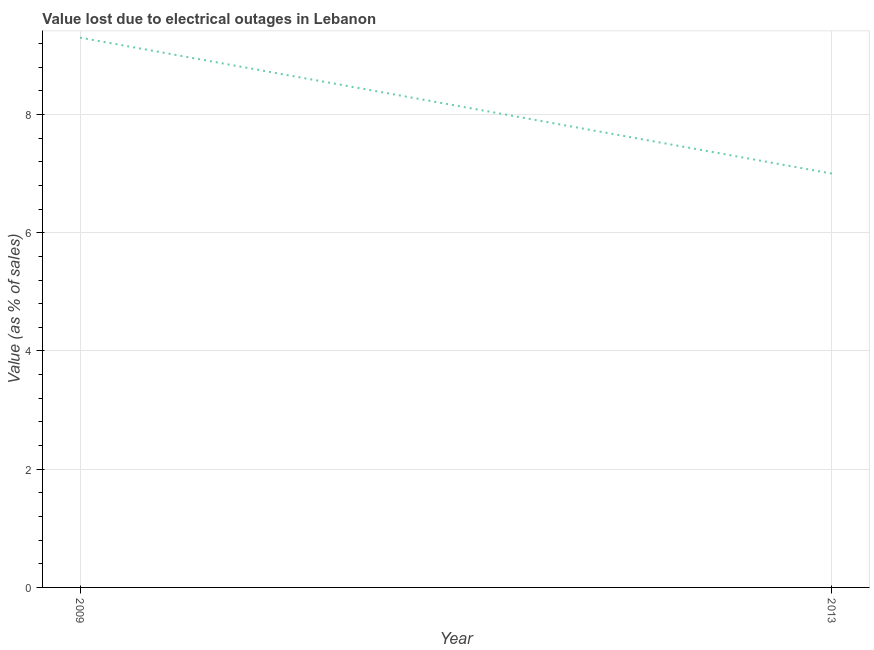What is the value lost due to electrical outages in 2009?
Keep it short and to the point. 9.3. Across all years, what is the maximum value lost due to electrical outages?
Make the answer very short. 9.3. Across all years, what is the minimum value lost due to electrical outages?
Your answer should be compact. 7. In which year was the value lost due to electrical outages maximum?
Make the answer very short. 2009. What is the difference between the value lost due to electrical outages in 2009 and 2013?
Offer a terse response. 2.3. What is the average value lost due to electrical outages per year?
Ensure brevity in your answer.  8.15. What is the median value lost due to electrical outages?
Your response must be concise. 8.15. In how many years, is the value lost due to electrical outages greater than 4.8 %?
Your response must be concise. 2. What is the ratio of the value lost due to electrical outages in 2009 to that in 2013?
Provide a short and direct response. 1.33. Does the value lost due to electrical outages monotonically increase over the years?
Offer a terse response. No. How many lines are there?
Ensure brevity in your answer.  1. How many years are there in the graph?
Give a very brief answer. 2. What is the difference between two consecutive major ticks on the Y-axis?
Give a very brief answer. 2. Does the graph contain any zero values?
Give a very brief answer. No. What is the title of the graph?
Provide a short and direct response. Value lost due to electrical outages in Lebanon. What is the label or title of the Y-axis?
Your answer should be very brief. Value (as % of sales). What is the Value (as % of sales) of 2013?
Make the answer very short. 7. What is the difference between the Value (as % of sales) in 2009 and 2013?
Ensure brevity in your answer.  2.3. What is the ratio of the Value (as % of sales) in 2009 to that in 2013?
Your answer should be very brief. 1.33. 